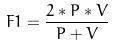<formula> <loc_0><loc_0><loc_500><loc_500>F 1 = \frac { 2 * P * V } { P + V }</formula> 